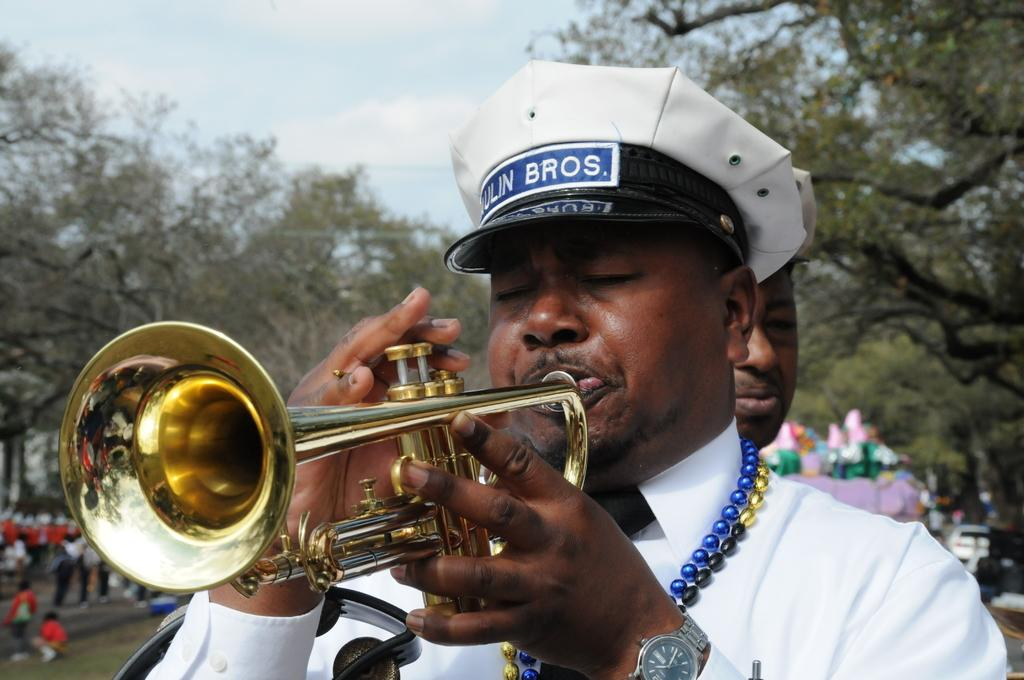What is the man in the image doing? The man is playing a trumpet in the image. Who else is present in the image besides the man playing the trumpet? There is a group of people in the image. What type of natural environment can be seen in the image? There are trees in the image. What can be seen in the background of the image? The sky is visible in the background of the image. How much money is the man holding while playing the trumpet in the image? There is no indication of money in the image; the man is playing the trumpet without any visible money. 